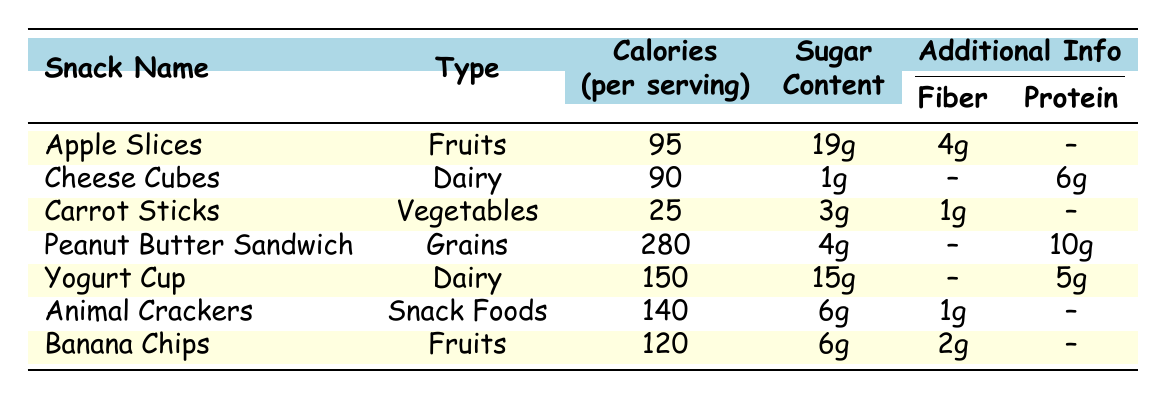What is the sugar content in Apple Slices? According to the table, the sugar content listed for Apple Slices is 19g.
Answer: 19g Which snack has the highest calories per serving? By comparing the values in the Calories column, the Peanut Butter Sandwich has the highest calories at 280 per serving.
Answer: Peanut Butter Sandwich Does Carrot Sticks contain more sugar than Cheese Cubes? The sugar content for Carrot Sticks is 3g, while for Cheese Cubes it is 1g. Since 3g is greater than 1g, Carrot Sticks contains more sugar.
Answer: Yes What is the total calorie count for Fruits (Apple Slices and Banana Chips)? The calories for Apple Slices is 95 and for Banana Chips is 120. Adding these two values gives us 95 + 120 = 215 calories.
Answer: 215 Is there any fruit snack that contains more fiber than Peanut Butter Sandwich? Peanut Butter Sandwich has no fiber listed (--), while Apple Slices and Banana Chips have 4g and 2g of fiber respectively. This means that neither fruit snack has more fiber than Peanut Butter Sandwich.
Answer: No What is the average calories per serving of all snacks listed in the table? The total calories from all snacks: 95 (Apple Slices) + 90 (Cheese Cubes) + 25 (Carrot Sticks) + 280 (Peanut Butter Sandwich) + 150 (Yogurt Cup) + 140 (Animal Crackers) + 120 (Banana Chips) = 900 calories. Since there are 7 snacks, the average is calculated as 900 divided by 7, which is approximately 128.57.
Answer: 128.57 Which snack type has the most recorded snacks in the table? Scanning through the table, Dairy appears twice (Cheese Cubes and Yogurt Cup), while all others appear only once. This indicates that Dairy has the most recorded snacks in the table.
Answer: Dairy Is there a dairy snack with more protein than the Yogurt Cup? The Yogurt Cup contains 5g of protein and the Cheese Cubes contain 6g. Since 6g is greater than 5g, Cheese Cubes has more protein than Yogurt Cup.
Answer: Yes What snack has the lowest sugar content? The table shows that Carrot Sticks has the lowest sugar content with only 3g.
Answer: Carrot Sticks 